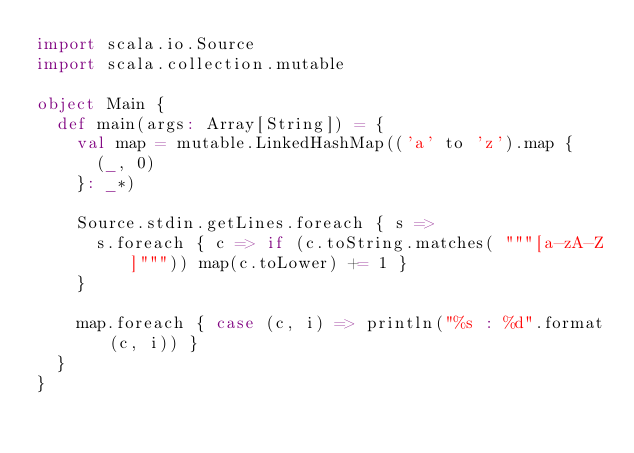Convert code to text. <code><loc_0><loc_0><loc_500><loc_500><_Scala_>import scala.io.Source
import scala.collection.mutable

object Main {
  def main(args: Array[String]) = {
    val map = mutable.LinkedHashMap(('a' to 'z').map {
      (_, 0)
    }: _*)

    Source.stdin.getLines.foreach { s =>
      s.foreach { c => if (c.toString.matches( """[a-zA-Z]""")) map(c.toLower) += 1 }
    }

    map.foreach { case (c, i) => println("%s : %d".format(c, i)) }
  }
}</code> 